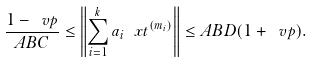Convert formula to latex. <formula><loc_0><loc_0><loc_500><loc_500>\frac { 1 - \ v p } { A B C } \leq \left \| \sum _ { i = 1 } ^ { k } a _ { i } \ x t ^ { ( m _ { i } ) } \right \| \leq A B D ( 1 + \ v p ) .</formula> 